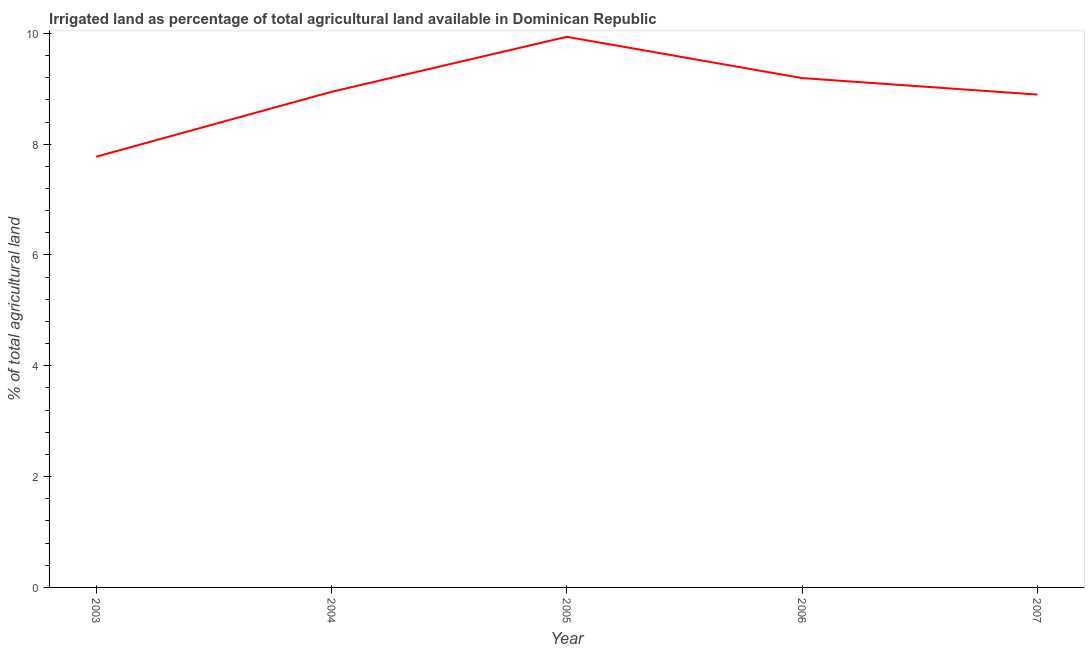What is the percentage of agricultural irrigated land in 2004?
Your answer should be very brief. 8.94. Across all years, what is the maximum percentage of agricultural irrigated land?
Keep it short and to the point. 9.94. Across all years, what is the minimum percentage of agricultural irrigated land?
Give a very brief answer. 7.77. In which year was the percentage of agricultural irrigated land maximum?
Your answer should be very brief. 2005. In which year was the percentage of agricultural irrigated land minimum?
Offer a very short reply. 2003. What is the sum of the percentage of agricultural irrigated land?
Provide a succinct answer. 44.75. What is the difference between the percentage of agricultural irrigated land in 2004 and 2006?
Provide a succinct answer. -0.25. What is the average percentage of agricultural irrigated land per year?
Offer a very short reply. 8.95. What is the median percentage of agricultural irrigated land?
Make the answer very short. 8.94. In how many years, is the percentage of agricultural irrigated land greater than 4.8 %?
Your answer should be very brief. 5. Do a majority of the years between 2005 and 2007 (inclusive) have percentage of agricultural irrigated land greater than 8.4 %?
Your response must be concise. Yes. What is the ratio of the percentage of agricultural irrigated land in 2003 to that in 2006?
Your answer should be very brief. 0.85. What is the difference between the highest and the second highest percentage of agricultural irrigated land?
Provide a succinct answer. 0.74. Is the sum of the percentage of agricultural irrigated land in 2004 and 2005 greater than the maximum percentage of agricultural irrigated land across all years?
Keep it short and to the point. Yes. What is the difference between the highest and the lowest percentage of agricultural irrigated land?
Ensure brevity in your answer.  2.16. In how many years, is the percentage of agricultural irrigated land greater than the average percentage of agricultural irrigated land taken over all years?
Offer a terse response. 2. Does the graph contain any zero values?
Provide a short and direct response. No. Does the graph contain grids?
Provide a short and direct response. No. What is the title of the graph?
Ensure brevity in your answer.  Irrigated land as percentage of total agricultural land available in Dominican Republic. What is the label or title of the Y-axis?
Your answer should be very brief. % of total agricultural land. What is the % of total agricultural land of 2003?
Offer a very short reply. 7.77. What is the % of total agricultural land of 2004?
Your answer should be compact. 8.94. What is the % of total agricultural land of 2005?
Keep it short and to the point. 9.94. What is the % of total agricultural land of 2006?
Your answer should be very brief. 9.19. What is the % of total agricultural land in 2007?
Provide a succinct answer. 8.9. What is the difference between the % of total agricultural land in 2003 and 2004?
Make the answer very short. -1.17. What is the difference between the % of total agricultural land in 2003 and 2005?
Your answer should be compact. -2.16. What is the difference between the % of total agricultural land in 2003 and 2006?
Make the answer very short. -1.42. What is the difference between the % of total agricultural land in 2003 and 2007?
Ensure brevity in your answer.  -1.12. What is the difference between the % of total agricultural land in 2004 and 2005?
Keep it short and to the point. -0.99. What is the difference between the % of total agricultural land in 2004 and 2006?
Ensure brevity in your answer.  -0.25. What is the difference between the % of total agricultural land in 2004 and 2007?
Offer a very short reply. 0.05. What is the difference between the % of total agricultural land in 2005 and 2006?
Provide a succinct answer. 0.74. What is the difference between the % of total agricultural land in 2005 and 2007?
Offer a very short reply. 1.04. What is the difference between the % of total agricultural land in 2006 and 2007?
Give a very brief answer. 0.3. What is the ratio of the % of total agricultural land in 2003 to that in 2004?
Provide a succinct answer. 0.87. What is the ratio of the % of total agricultural land in 2003 to that in 2005?
Your answer should be compact. 0.78. What is the ratio of the % of total agricultural land in 2003 to that in 2006?
Your response must be concise. 0.85. What is the ratio of the % of total agricultural land in 2003 to that in 2007?
Give a very brief answer. 0.87. What is the ratio of the % of total agricultural land in 2004 to that in 2005?
Offer a terse response. 0.9. What is the ratio of the % of total agricultural land in 2004 to that in 2006?
Provide a succinct answer. 0.97. What is the ratio of the % of total agricultural land in 2004 to that in 2007?
Your answer should be compact. 1.01. What is the ratio of the % of total agricultural land in 2005 to that in 2006?
Provide a succinct answer. 1.08. What is the ratio of the % of total agricultural land in 2005 to that in 2007?
Your answer should be very brief. 1.12. What is the ratio of the % of total agricultural land in 2006 to that in 2007?
Offer a terse response. 1.03. 